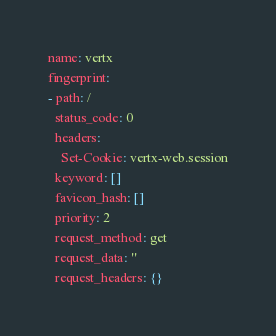<code> <loc_0><loc_0><loc_500><loc_500><_YAML_>name: vertx
fingerprint:
- path: /
  status_code: 0
  headers:
    Set-Cookie: vertx-web.session
  keyword: []
  favicon_hash: []
  priority: 2
  request_method: get
  request_data: ''
  request_headers: {}
</code> 